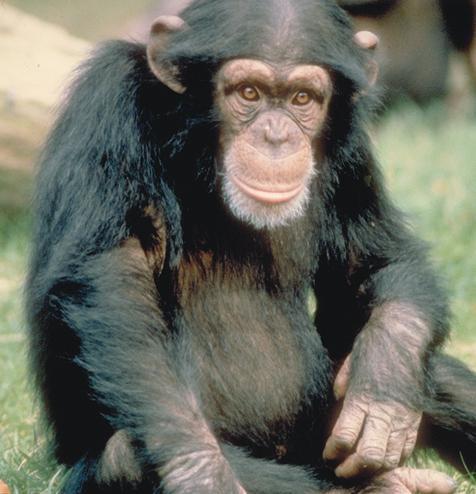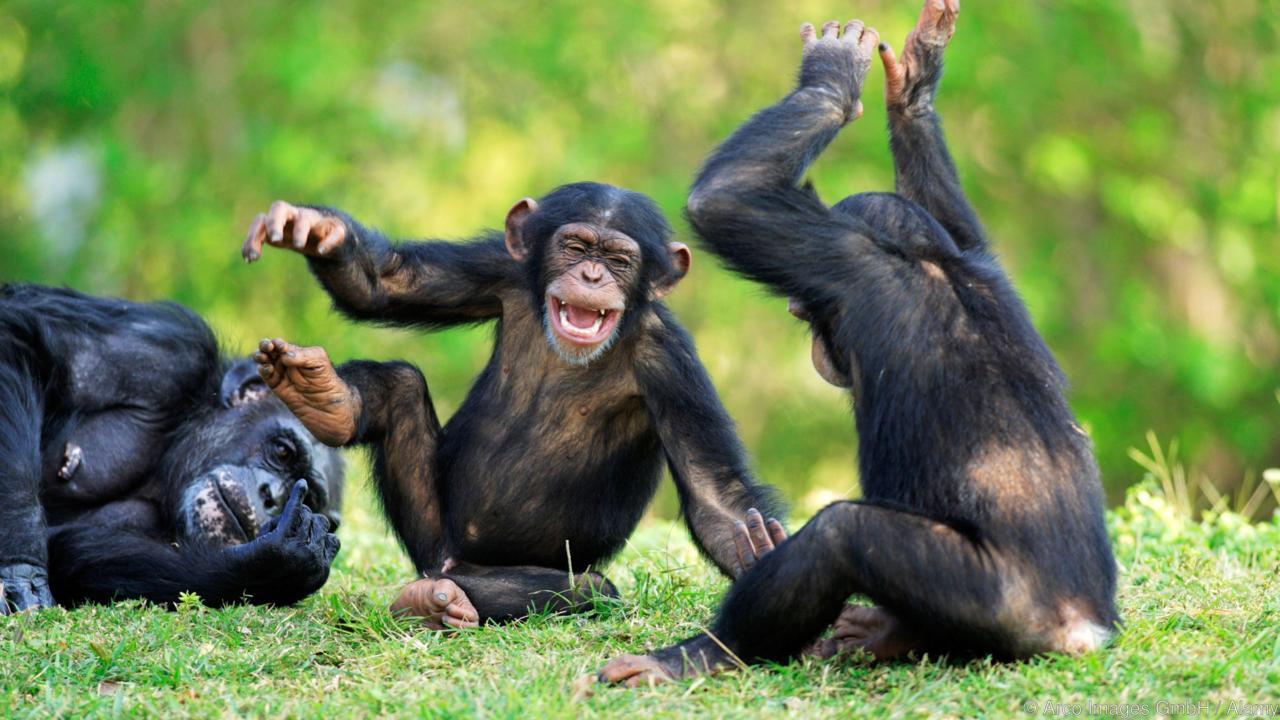The first image is the image on the left, the second image is the image on the right. Given the left and right images, does the statement "At least one of the images shows more than one chimpanzee." hold true? Answer yes or no. Yes. The first image is the image on the left, the second image is the image on the right. Evaluate the accuracy of this statement regarding the images: "The is one monkey in the image on the right.". Is it true? Answer yes or no. No. 